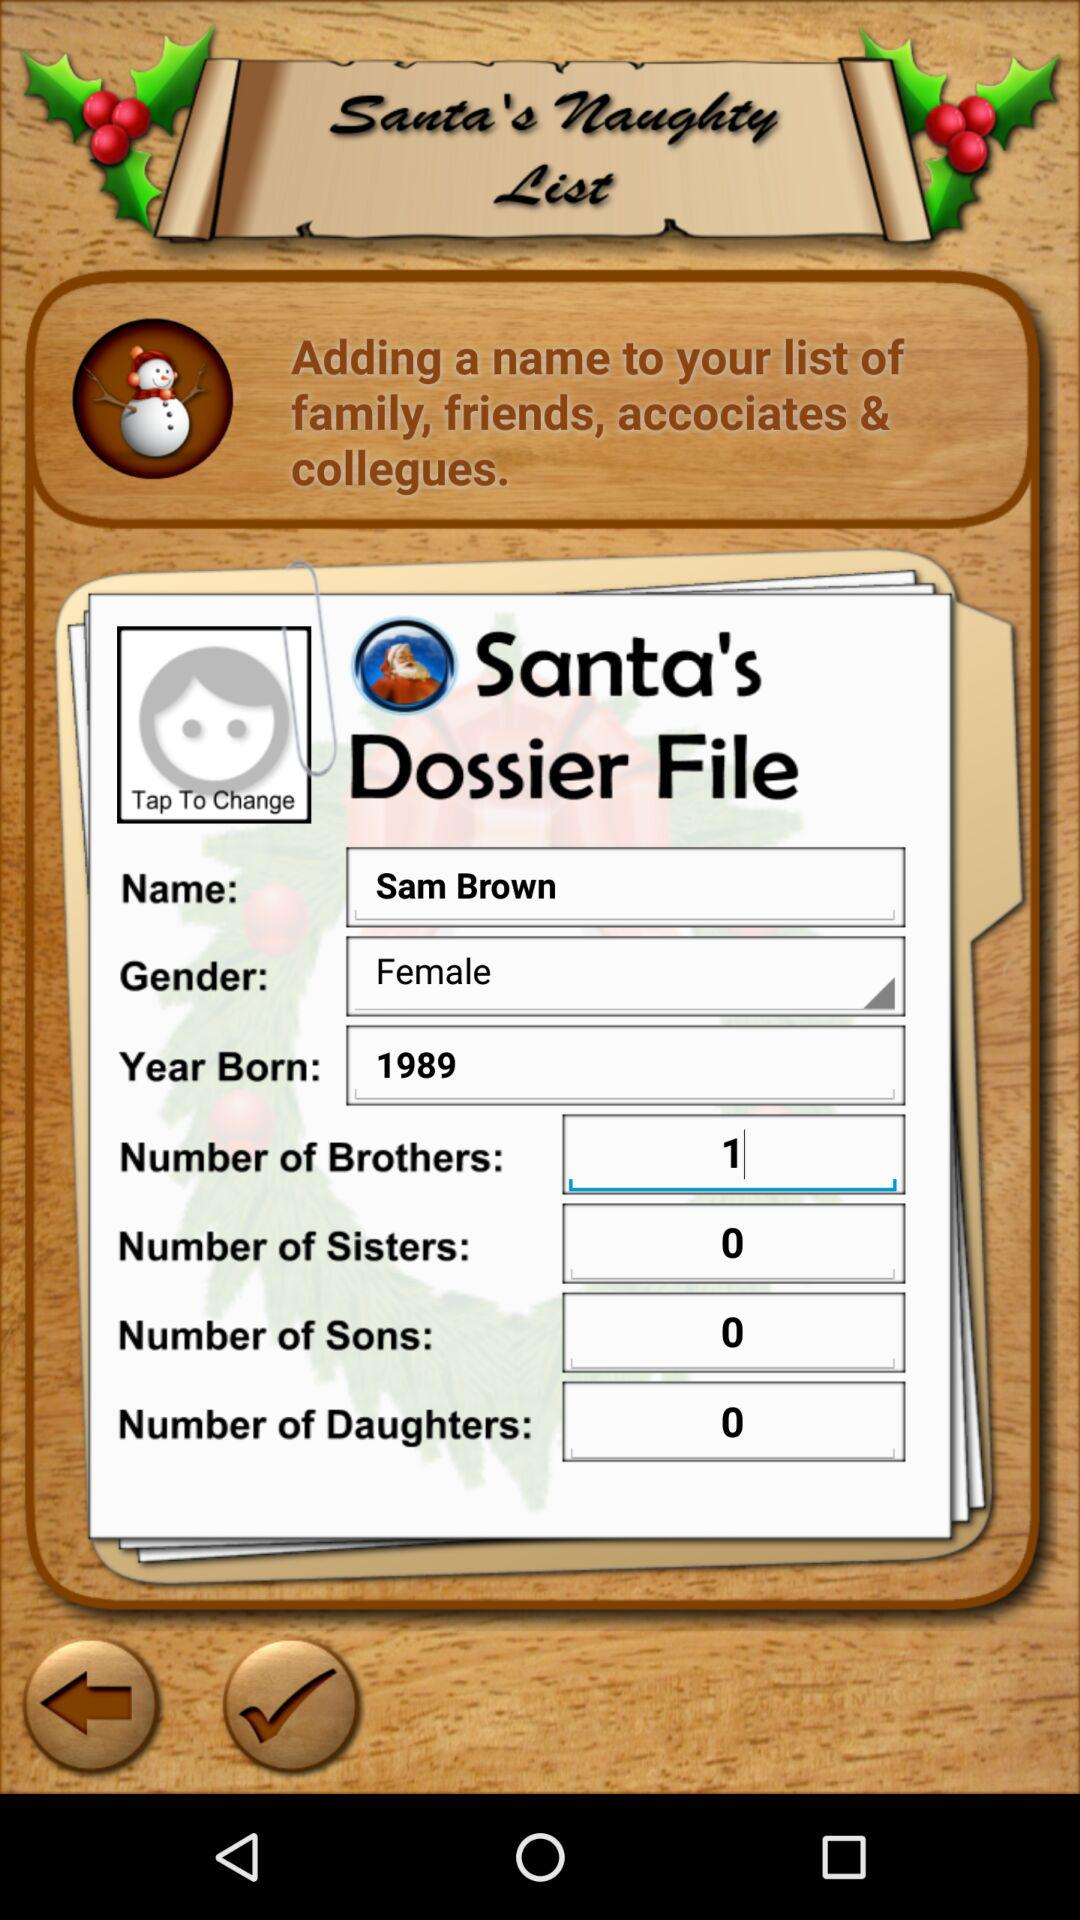What is the user's total number of daughters? The user's total number of daughters is 0. 